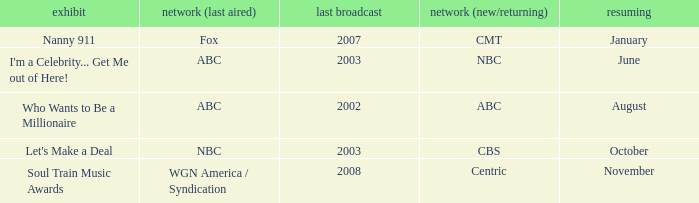When did soul train music awards return? November. 